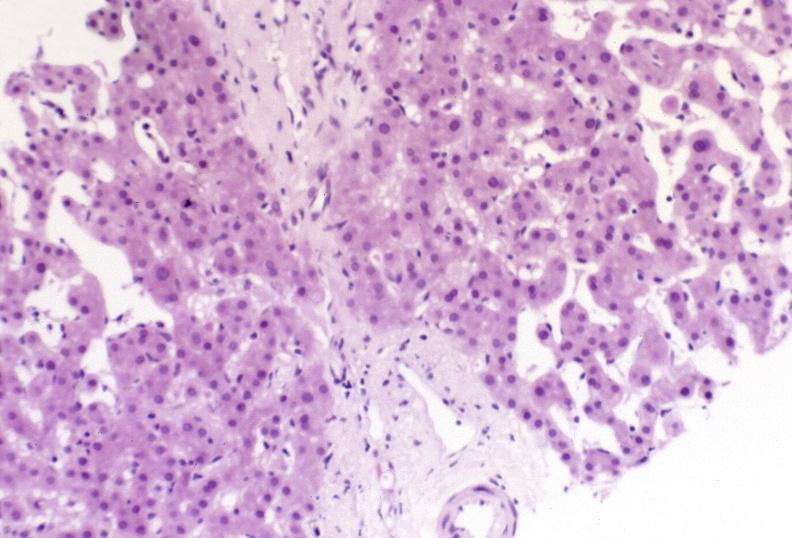s leiomyosarcoma present?
Answer the question using a single word or phrase. No 